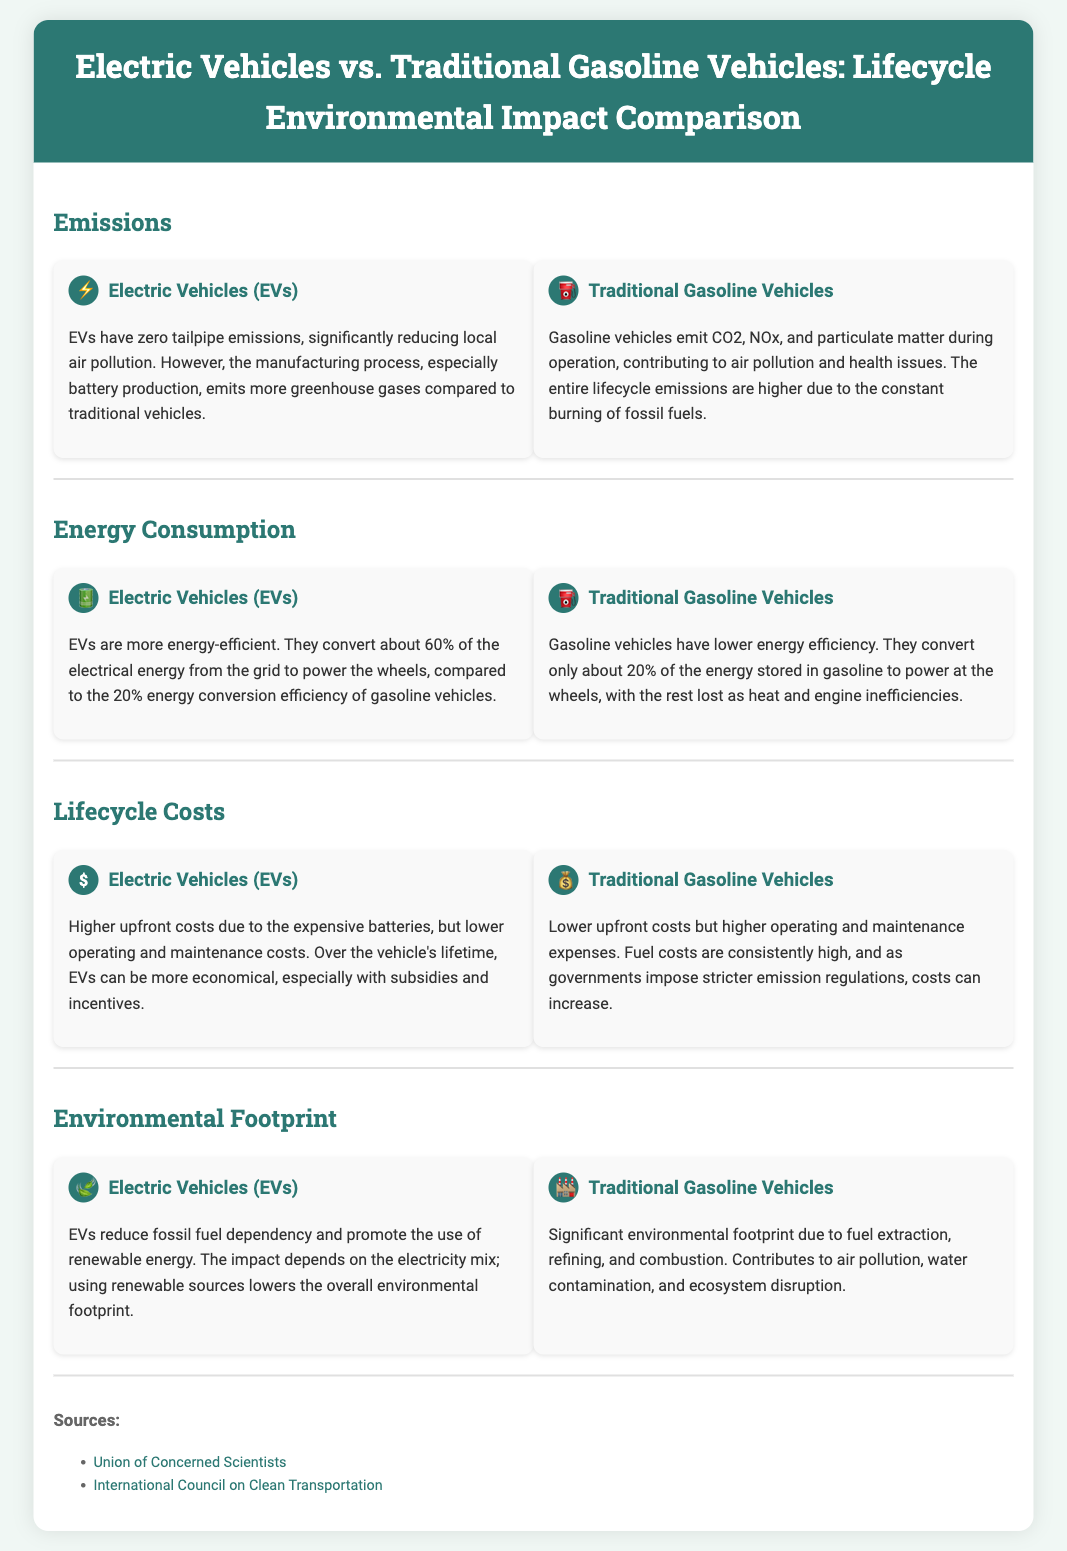What is the overall emissions comparison between EVs and gasoline vehicles? EVs have zero tailpipe emissions, while gasoline vehicles emit CO2, NOx, and particulate matter during operation.
Answer: EVs have zero tailpipe emissions; gasoline vehicles emit pollutants What percentage of electrical energy do EVs convert? The document states that EVs convert about 60% of the electrical energy from the grid to power the wheels.
Answer: 60% What is a major drawback of traditional gasoline vehicles regarding emissions? Traditional gasoline vehicles have higher lifecycle emissions due to the constant burning of fossil fuels.
Answer: Higher lifecycle emissions What do EVs reduce in terms of fossil fuel usage? The impact of EVs includes reducing fossil fuel dependency and promoting the use of renewable energy.
Answer: Fossil fuel dependency What are the higher costs associated with EVs primarily due to? EVs incur higher upfront costs primarily due to the expensive batteries.
Answer: Expensive batteries How much energy do traditional gasoline vehicles convert? The document mentions that traditional gasoline vehicles convert only about 20% of the energy stored in gasoline to power at the wheels.
Answer: 20% Which vehicle type usually incurs lower operating costs over its lifetime? According to the infographic, EVs typically have lower operating and maintenance costs over the vehicle's lifetime.
Answer: Electric Vehicles What environmental benefit do EVs have regarding electricity sources? The document states that the environmental impact of EVs can be lower if renewable sources are used for electricity.
Answer: Renewable sources What does the document outline about the lifecycle costs of traditional gasoline vehicles? The cost analysis indicates that gasoline vehicles have lower upfront costs but higher operating and maintenance expenses.
Answer: Lower upfront costs but higher expenses 